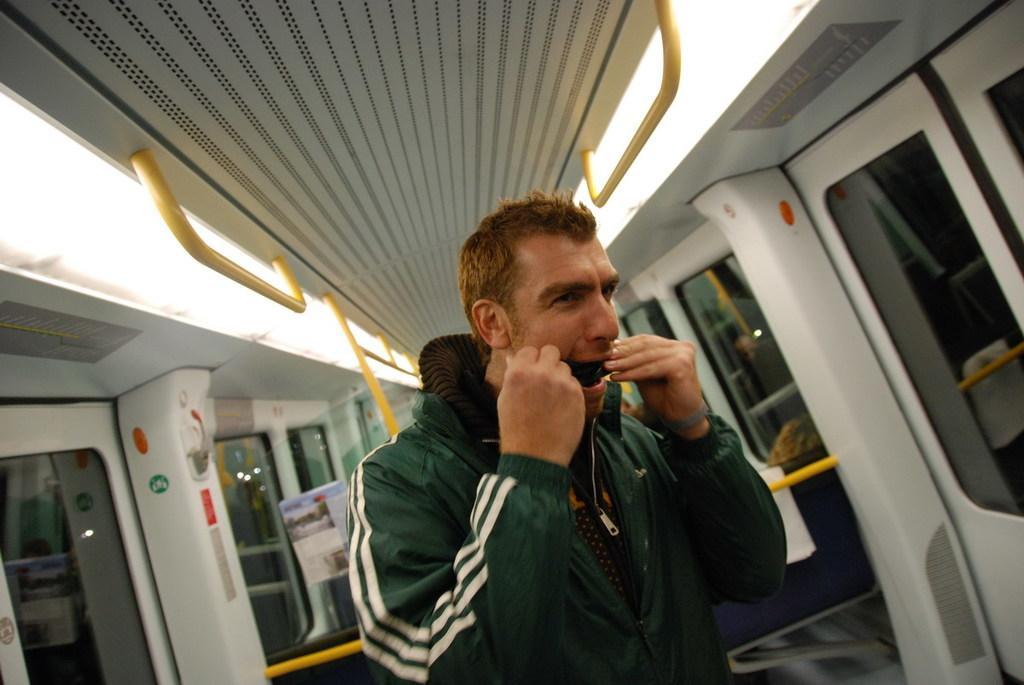In one or two sentences, can you explain what this image depicts? In this image we can see a man standing in a vehicle. In the background there are doors. At the top there are rods and we can see a board. 